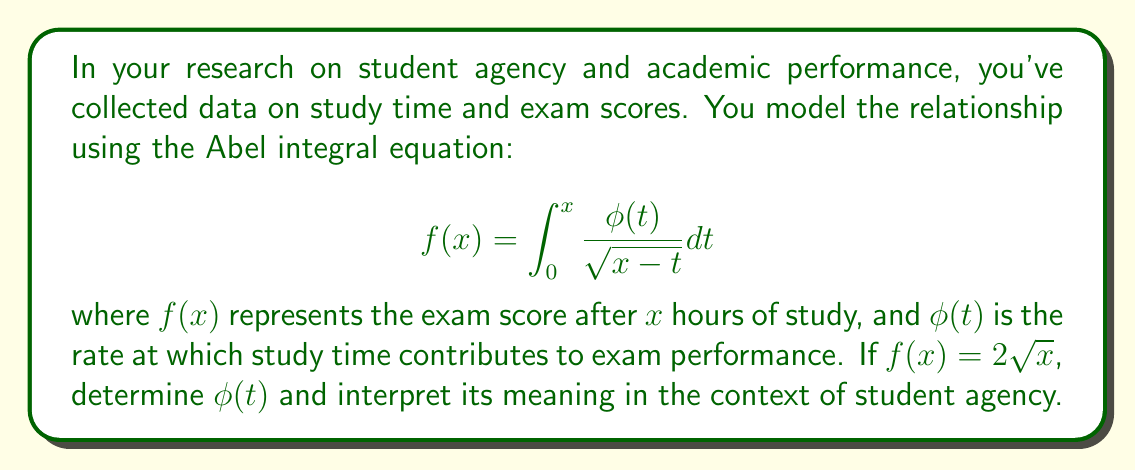Give your solution to this math problem. To solve this Abel integral equation, we follow these steps:

1) We start with the given equation:
   $$f(x) = \int_0^x \frac{\phi(t)}{\sqrt{x-t}} dt$$

2) We're given that $f(x) = 2\sqrt{x}$. To solve for $\phi(t)$, we use the inverse Abel transform:
   $$\phi(t) = \frac{1}{\pi} \frac{d}{dt} \int_0^t \frac{f'(x)}{\sqrt{t-x}} dx$$

3) First, let's find $f'(x)$:
   $$f'(x) = \frac{d}{dx}(2\sqrt{x}) = \frac{1}{\sqrt{x}}$$

4) Now we substitute this into the inverse Abel transform:
   $$\phi(t) = \frac{1}{\pi} \frac{d}{dt} \int_0^t \frac{1/\sqrt{x}}{\sqrt{t-x}} dx$$

5) This integral can be evaluated:
   $$\int_0^t \frac{1/\sqrt{x}}{\sqrt{t-x}} dx = \pi$$

6) Therefore:
   $$\phi(t) = \frac{1}{\pi} \frac{d}{dt} (\pi) = 0$$

7) Interpretation: $\phi(t) = 0$ means that the rate at which study time contributes to exam performance is constant. In terms of student agency, this suggests that each additional hour of study contributes equally to the exam score, regardless of how much the student has already studied. This could indicate that students maintain consistent focus and effectiveness throughout their study sessions, demonstrating high levels of agency in their learning process.
Answer: $\phi(t) = 0$ 